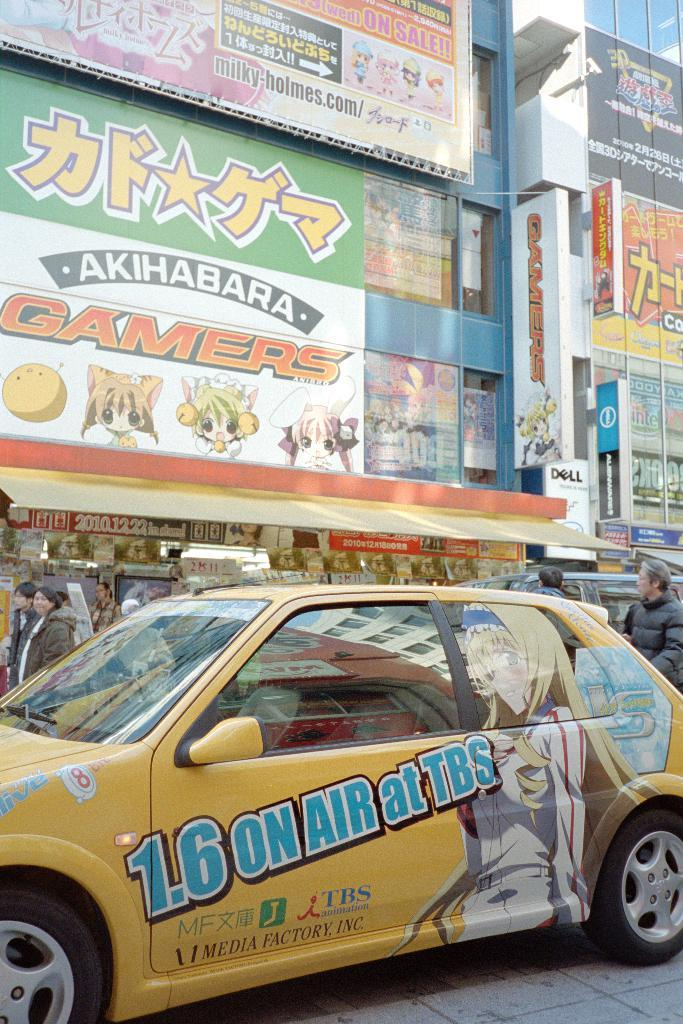Provide a one-sentence caption for the provided image. A yellow car with anime characters on it is driving past a building that says Gamers. 